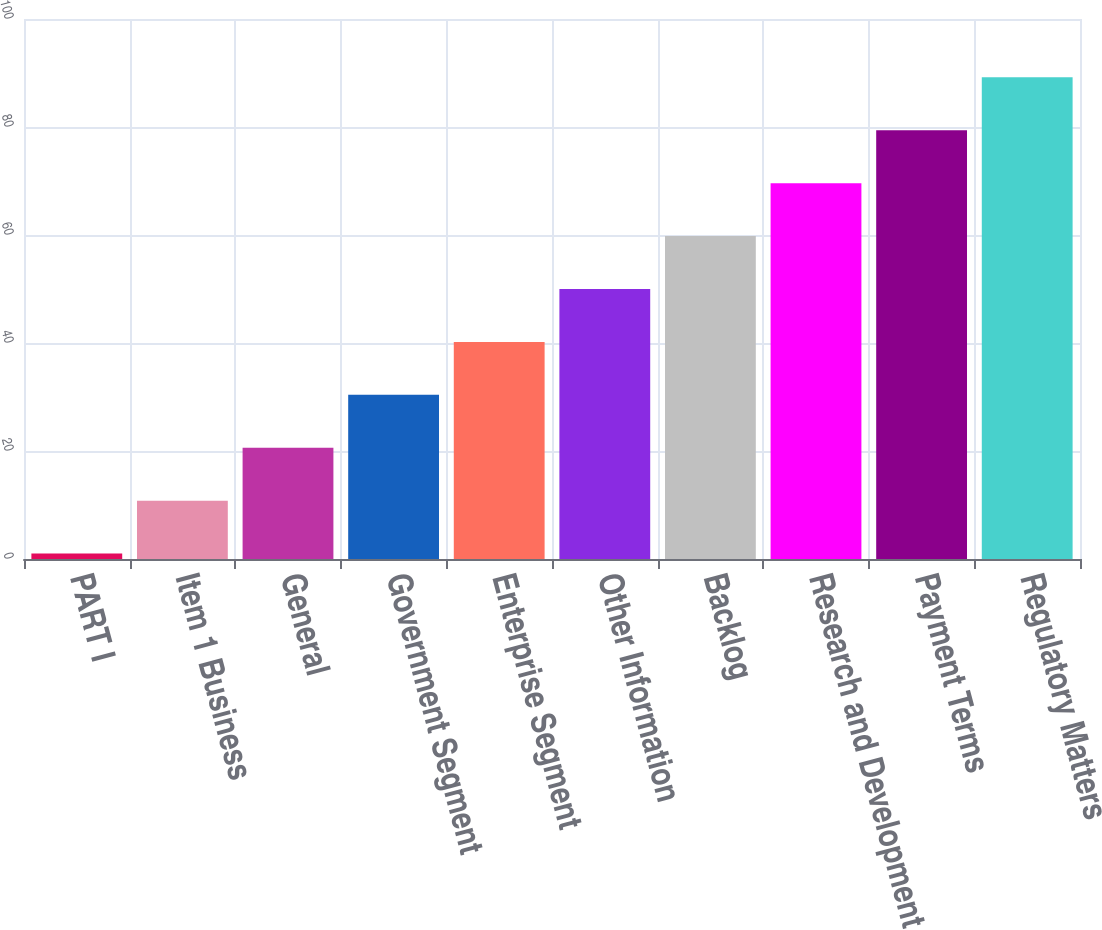<chart> <loc_0><loc_0><loc_500><loc_500><bar_chart><fcel>PART I<fcel>Item 1 Business<fcel>General<fcel>Government Segment<fcel>Enterprise Segment<fcel>Other Information<fcel>Backlog<fcel>Research and Development<fcel>Payment Terms<fcel>Regulatory Matters<nl><fcel>1<fcel>10.8<fcel>20.6<fcel>30.4<fcel>40.2<fcel>50<fcel>59.8<fcel>69.6<fcel>79.4<fcel>89.2<nl></chart> 